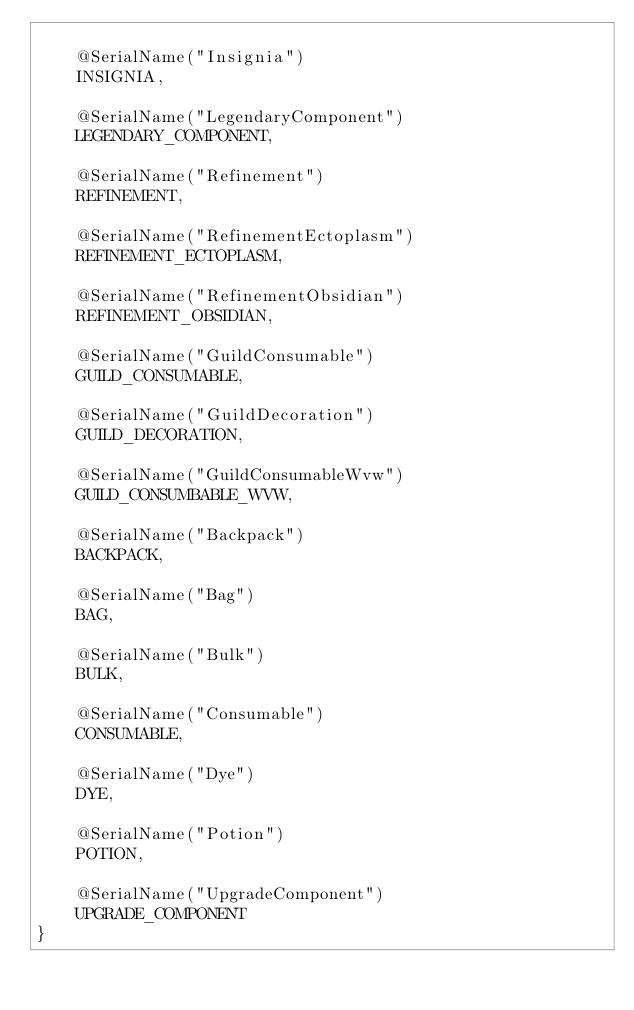<code> <loc_0><loc_0><loc_500><loc_500><_Kotlin_>
    @SerialName("Insignia")
    INSIGNIA,

    @SerialName("LegendaryComponent")
    LEGENDARY_COMPONENT,

    @SerialName("Refinement")
    REFINEMENT,

    @SerialName("RefinementEctoplasm")
    REFINEMENT_ECTOPLASM,

    @SerialName("RefinementObsidian")
    REFINEMENT_OBSIDIAN,

    @SerialName("GuildConsumable")
    GUILD_CONSUMABLE,

    @SerialName("GuildDecoration")
    GUILD_DECORATION,

    @SerialName("GuildConsumableWvw")
    GUILD_CONSUMBABLE_WVW,

    @SerialName("Backpack")
    BACKPACK,

    @SerialName("Bag")
    BAG,

    @SerialName("Bulk")
    BULK,

    @SerialName("Consumable")
    CONSUMABLE,

    @SerialName("Dye")
    DYE,

    @SerialName("Potion")
    POTION,

    @SerialName("UpgradeComponent")
    UPGRADE_COMPONENT
}</code> 